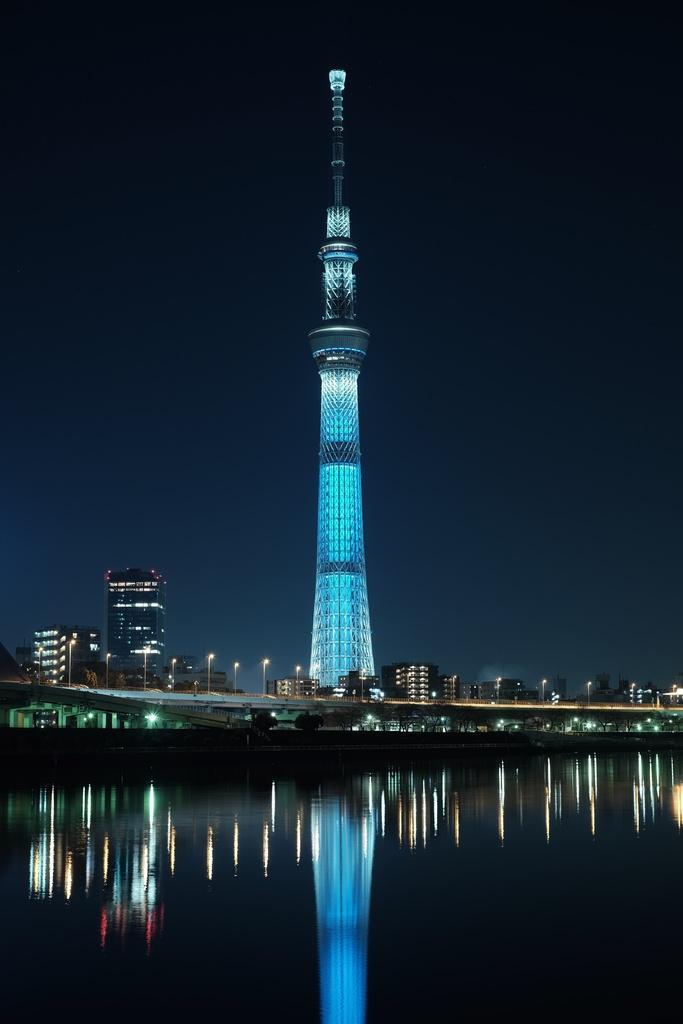Can you describe this image briefly? In this image, we can see a tower, buildings, light poles and trees. At the bottom of the image, we can see water. On the water, we can see reflections. Background we can see the sky. 